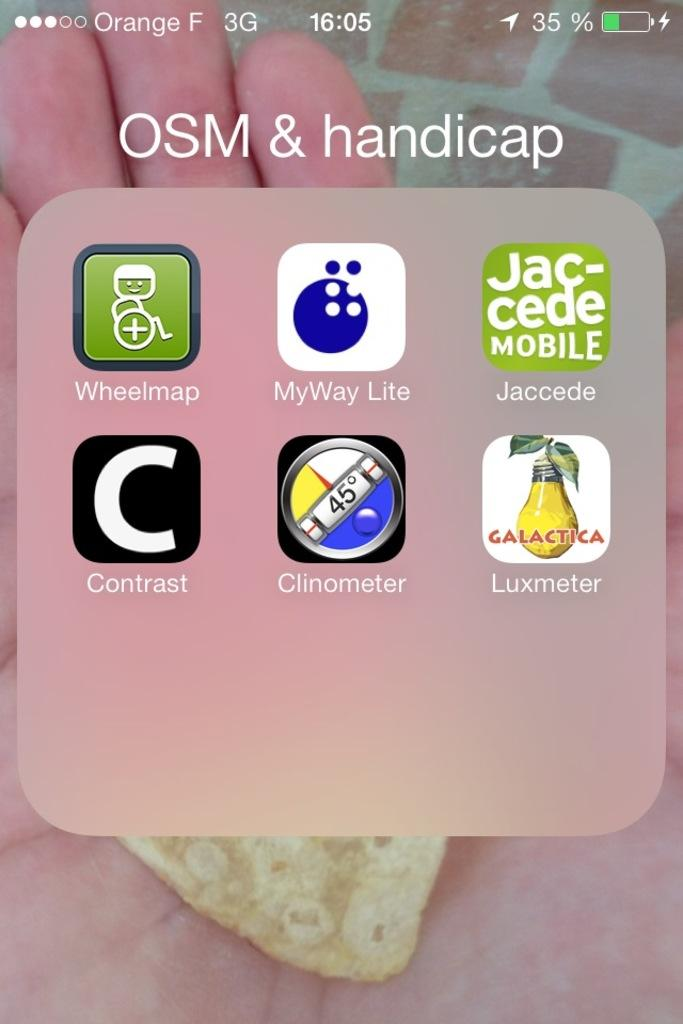What can be seen in the image besides writing? There are icons in the image. Can you describe the writing in the image? Yes, there is writing on the image. What is the person in the background of the image holding? There is an object in a person's hand in the background of the image. What type of pie is being served on the beach in the image? There is no pie or beach present in the image; it features icons, writing, and an object in a person's hand in the background. How is the fuel being used in the image? There is no fuel present in the image. 